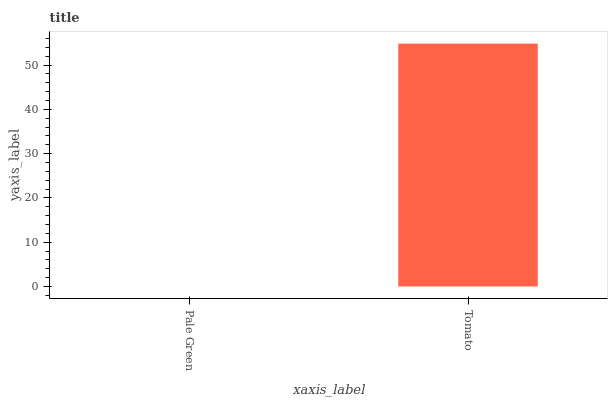Is Pale Green the minimum?
Answer yes or no. Yes. Is Tomato the maximum?
Answer yes or no. Yes. Is Tomato the minimum?
Answer yes or no. No. Is Tomato greater than Pale Green?
Answer yes or no. Yes. Is Pale Green less than Tomato?
Answer yes or no. Yes. Is Pale Green greater than Tomato?
Answer yes or no. No. Is Tomato less than Pale Green?
Answer yes or no. No. Is Tomato the high median?
Answer yes or no. Yes. Is Pale Green the low median?
Answer yes or no. Yes. Is Pale Green the high median?
Answer yes or no. No. Is Tomato the low median?
Answer yes or no. No. 